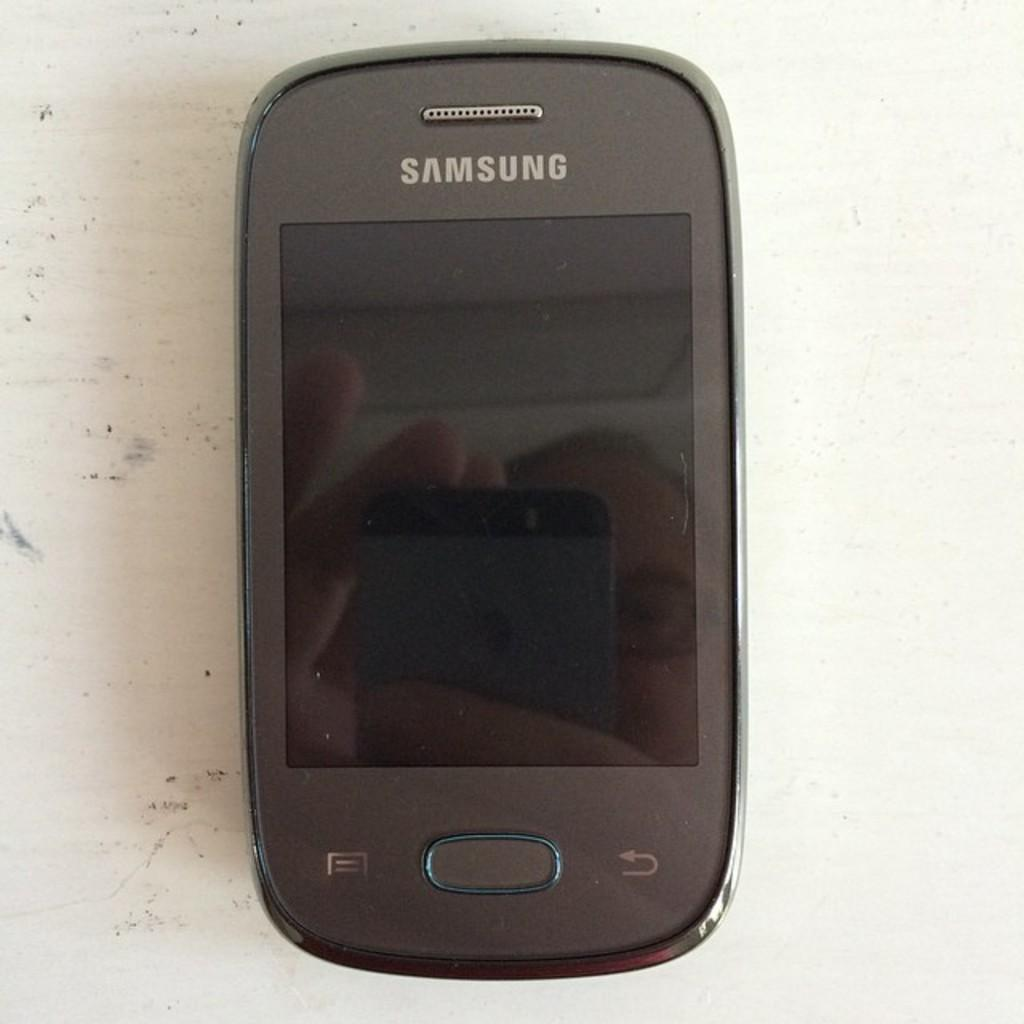<image>
Give a short and clear explanation of the subsequent image. an old samsung cellular device sits powered off on a table. 